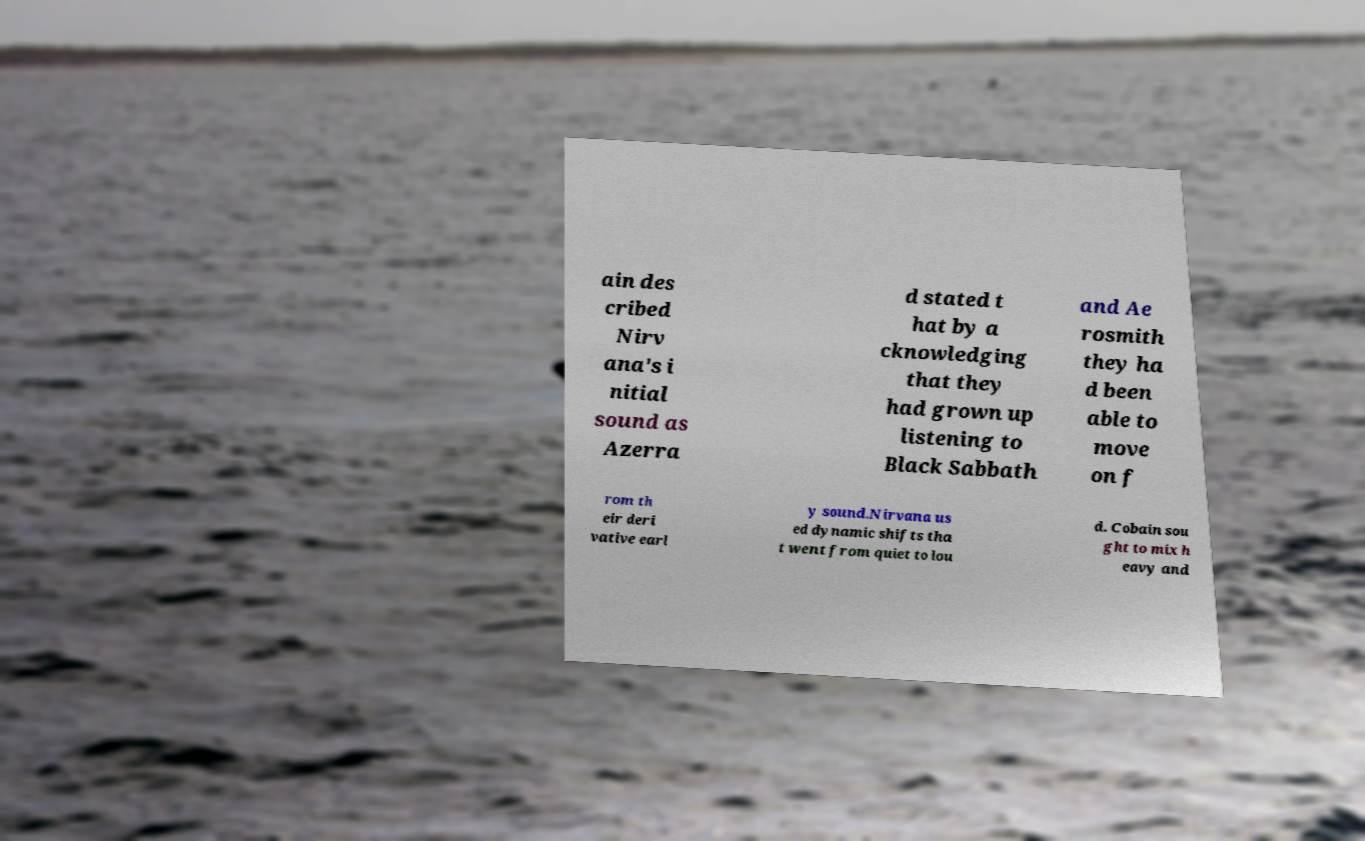Could you assist in decoding the text presented in this image and type it out clearly? ain des cribed Nirv ana's i nitial sound as Azerra d stated t hat by a cknowledging that they had grown up listening to Black Sabbath and Ae rosmith they ha d been able to move on f rom th eir deri vative earl y sound.Nirvana us ed dynamic shifts tha t went from quiet to lou d. Cobain sou ght to mix h eavy and 